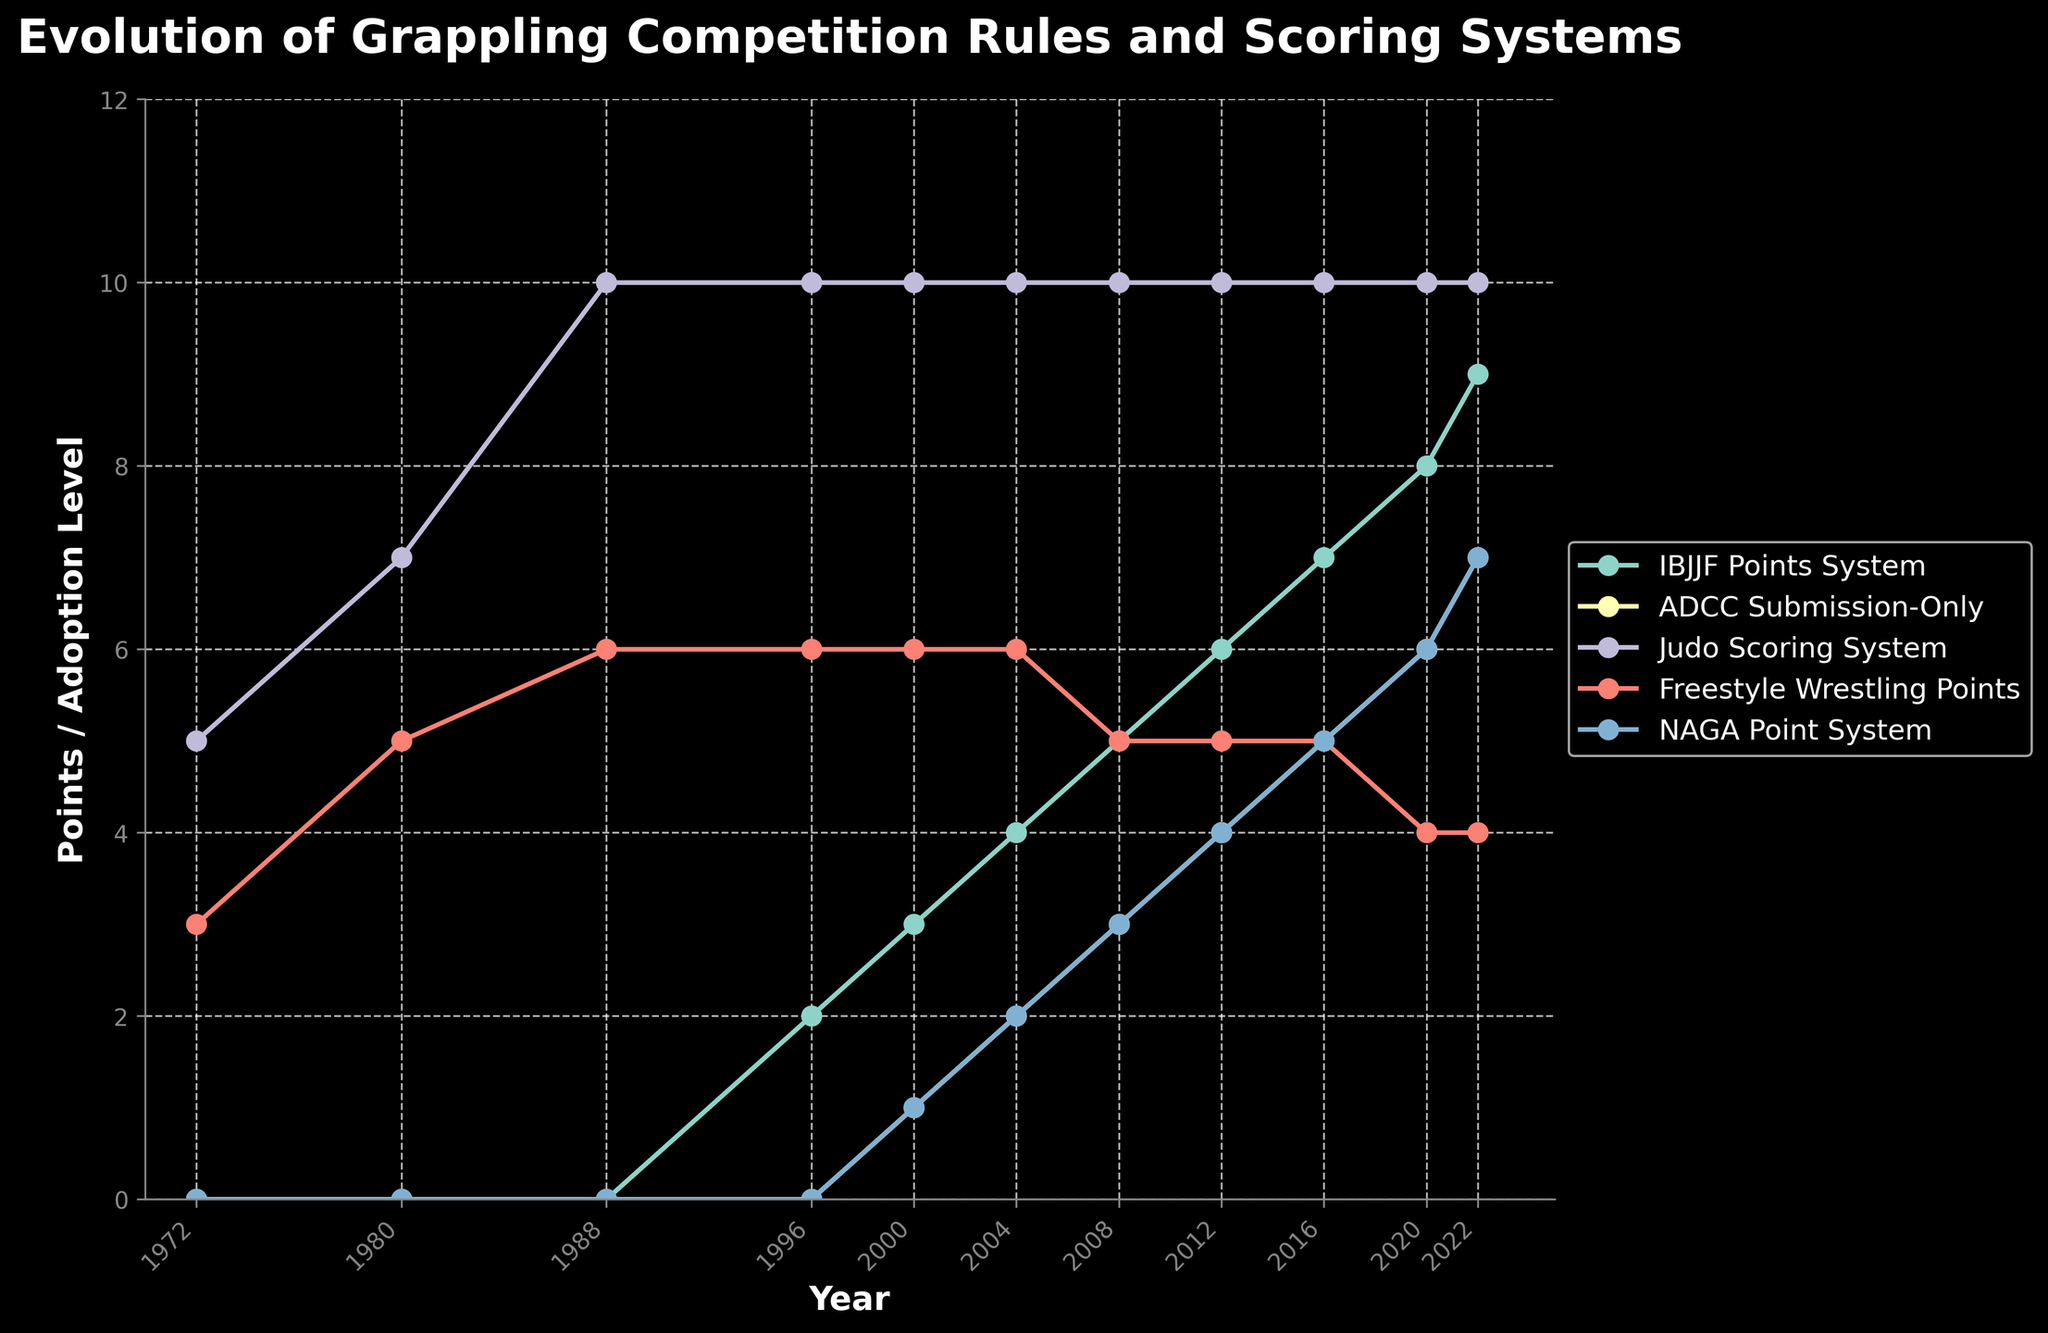What year did the IBJJF Points System start to be adopted? By examining the trend in the plot, the IBJJF Points System begins at a value of 0 and only changes to a non-zero value in 1996.
Answer: 1996 Which competition scoring system has remained constant over the past 50 years? Observing the lines in the plot, the line for Judo Scoring System consistently remains at 10 from 1972 to 2022.
Answer: Judo Scoring System In which year did NAGA Point System reach a value of 5? Trace the NAGA Point System line and note the corresponding year when it reaches 5 points, which is in 2016.
Answer: 2016 Which scoring system had the most significant increase between 2000 and 2022? Calculate the difference for each scoring system between 2000 and 2022 and compare them: IBJJF increased by 6, ADCC by 6, Judo remained the same, Freestyle Wrestling decreased by 2, and NAGA increased by 6. IBJJF, ADCC, and NAGA all increased by 6 points.
Answer: IBJJF, ADCC, NAGA What is the total of the Freestyle Wrestling Points in 1972 and 2022 combined? The Freestyle Wrestling Points in 1972 are 3 and in 2022 they are 4. By adding them together: 3 + 4 = 7.
Answer: 7 Which scoring system shows a decrease between 2008 and 2020? Look for lines that decline between these years. The line for Freestyle Wrestling Points goes from 5 in 2008 to 4 in 2020, showing a decrease.
Answer: Freestyle Wrestling Points In which year were both the IBJJF Points System and ADCC Submission-Only at values below 5? Identify the points where both IBJJF and ADCC are below 5. This happens in the year 2004, with IBJJF at 4 and ADCC at 2.
Answer: 2004 What is the average value of ADCC Submission-Only points from 2000 to 2022? Adding the ADCC Submission-Only points from 2000 to 2022: 1 + 2 + 3 + 4 + 5 + 6 + 7 and dividing by the number of years (7): (1+2+3+4+5+6+7)/7 = 28/7 = 4.
Answer: 4 